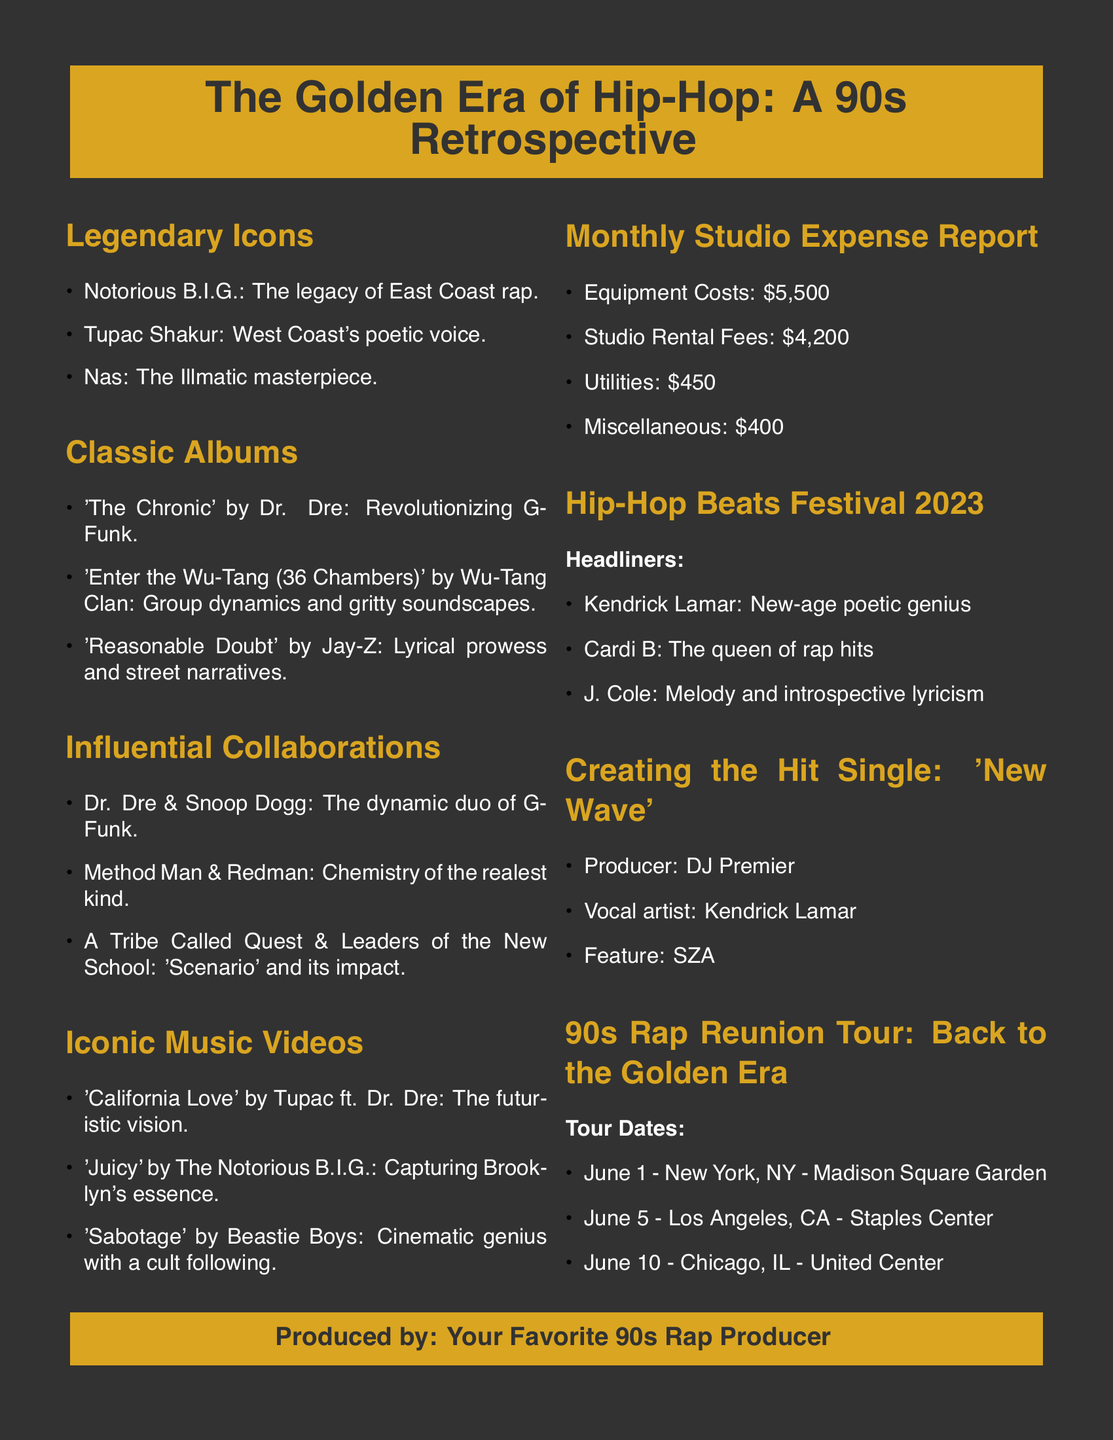What are the names of the legendary hip-hop icons featured? The document lists Notorious B.I.G., Tupac Shakur, and Nas as legendary hip-hop icons.
Answer: Notorious B.I.G., Tupac Shakur, Nas What is the total equipment cost in the studio expense report? The studio expense report specifies that the equipment costs are $5,500.
Answer: $5,500 Who produced the hit single 'New Wave'? The document states that DJ Premier is the producer of the hit single 'New Wave'.
Answer: DJ Premier What is the date of the concert in New York? The tour itinerary shows that the New York concert is scheduled for June 1.
Answer: June 1 How many headliners are listed for the Hip-Hop Beats Festival 2023? The document mentions three headliners: Kendrick Lamar, Cardi B, and J. Cole.
Answer: Three What was the iconic music video featuring Tupac and Dr. Dre? The document lists 'California Love' as the iconic music video featuring Tupac and Dr. Dre.
Answer: California Love How much was spent on studio rental fees? The report indicates that the studio rental fees are $4,200.
Answer: $4,200 Which album is referenced as 'the Illmatic masterpiece'? The document refers to 'Illmatic' by Nas as the masterpiece.
Answer: Illmatic What is the total number of tour dates listed? The tour itinerary displays three tour dates.
Answer: Three 